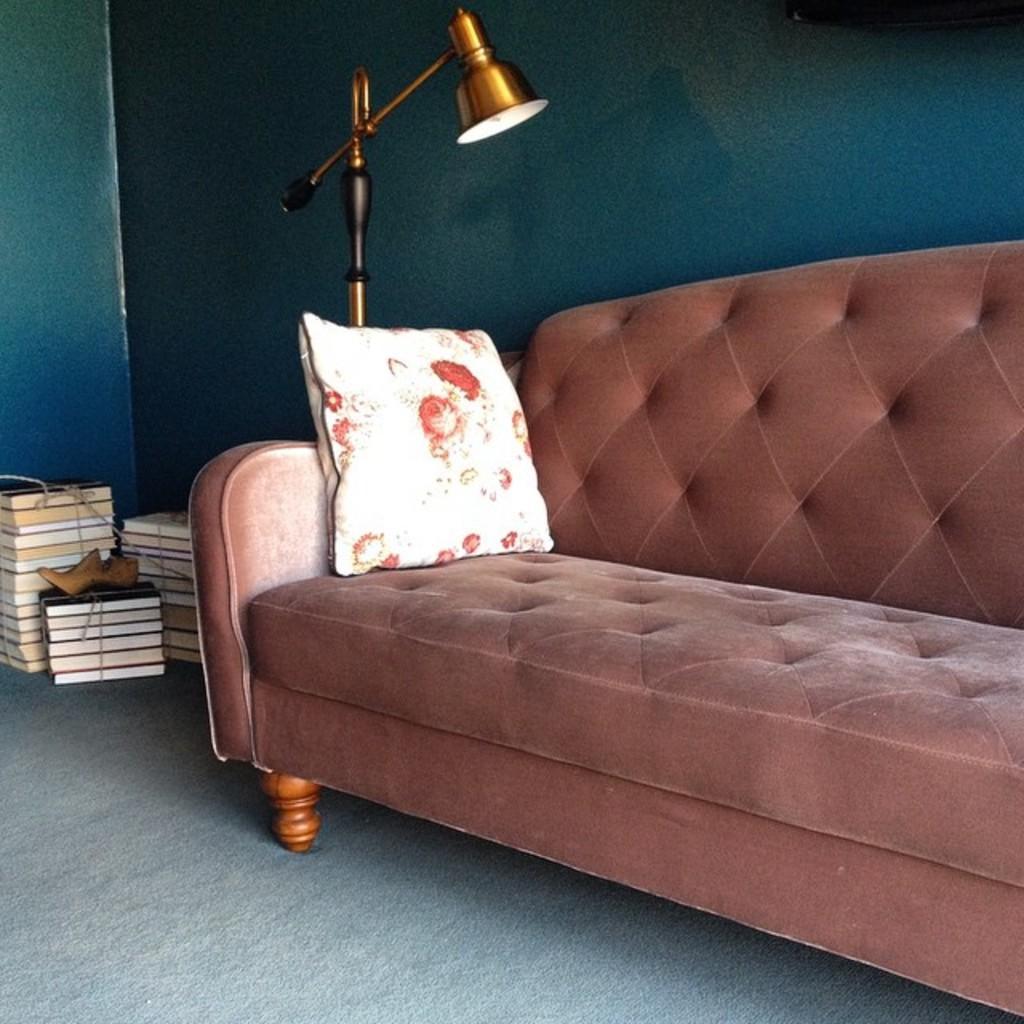Describe this image in one or two sentences. In this image their is a sofa and a pillow on it and there is a lamp on the top of it. At the bottom there are books and a shoe. at the background there is a wall. 